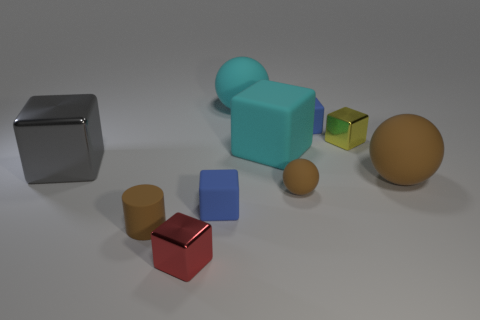Can you tell me what time of day it appears to be based on the lighting in this image? The nuances in the lighting suggest an artificial source rather than natural sunlight, such as is commonly found in a controlled indoor environment, making it difficult to determine the time of day based solely on this image. 